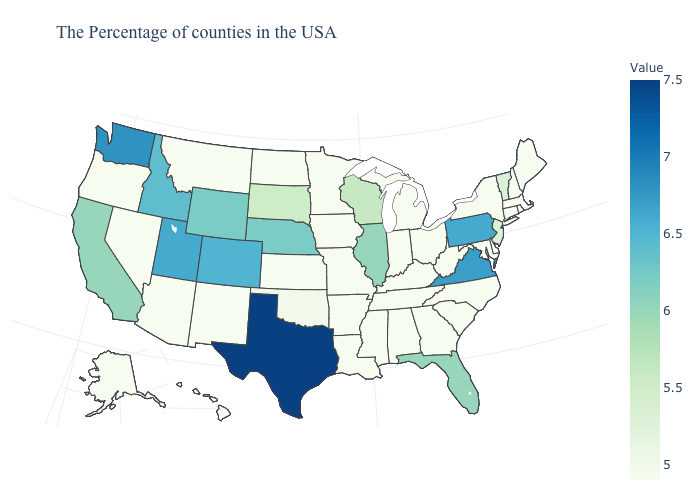Among the states that border North Dakota , which have the lowest value?
Keep it brief. Minnesota, Montana. Does Illinois have the highest value in the MidWest?
Be succinct. No. 